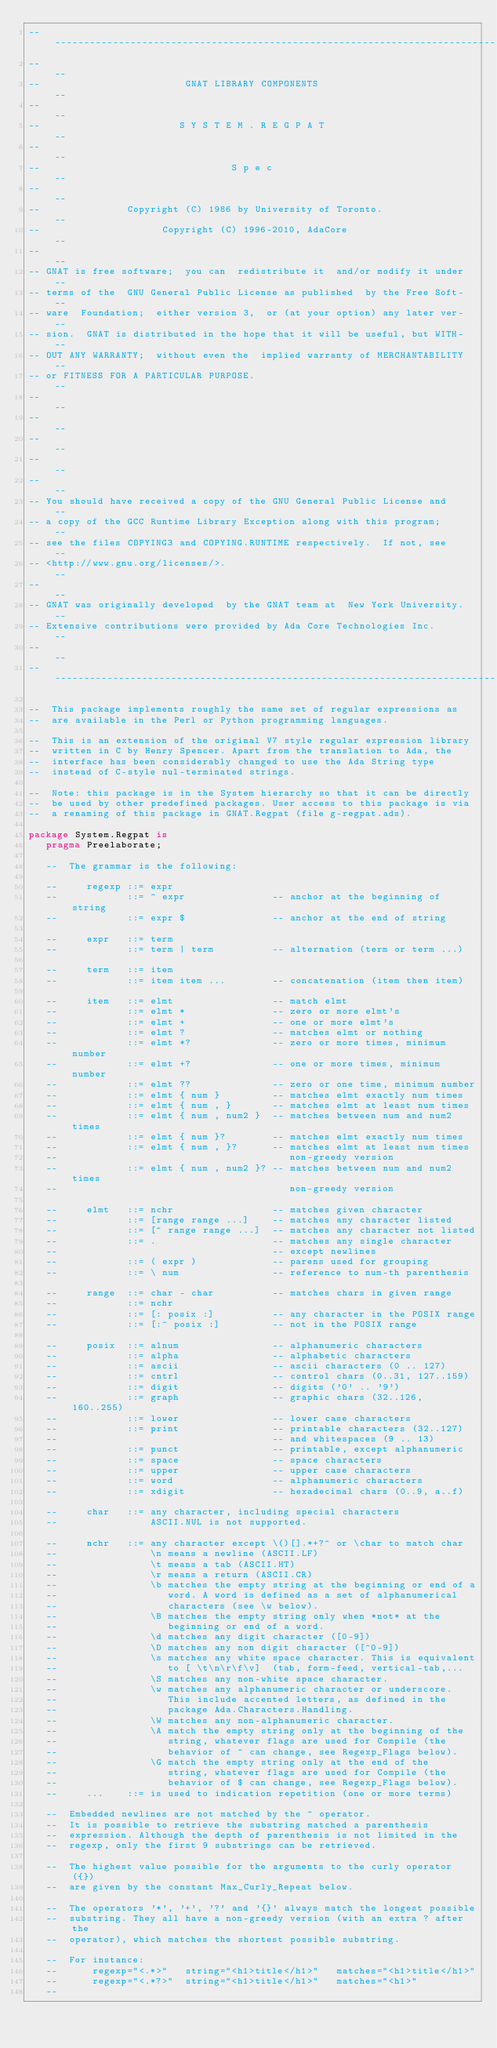Convert code to text. <code><loc_0><loc_0><loc_500><loc_500><_Ada_>------------------------------------------------------------------------------
--                                                                          --
--                         GNAT LIBRARY COMPONENTS                          --
--                                                                          --
--                        S Y S T E M . R E G P A T                         --
--                                                                          --
--                                 S p e c                                  --
--                                                                          --
--               Copyright (C) 1986 by University of Toronto.               --
--                     Copyright (C) 1996-2010, AdaCore                     --
--                                                                          --
-- GNAT is free software;  you can  redistribute it  and/or modify it under --
-- terms of the  GNU General Public License as published  by the Free Soft- --
-- ware  Foundation;  either version 3,  or (at your option) any later ver- --
-- sion.  GNAT is distributed in the hope that it will be useful, but WITH- --
-- OUT ANY WARRANTY;  without even the  implied warranty of MERCHANTABILITY --
-- or FITNESS FOR A PARTICULAR PURPOSE.                                     --
--                                                                          --
--                                                                          --
--                                                                          --
--                                                                          --
--                                                                          --
-- You should have received a copy of the GNU General Public License and    --
-- a copy of the GCC Runtime Library Exception along with this program;     --
-- see the files COPYING3 and COPYING.RUNTIME respectively.  If not, see    --
-- <http://www.gnu.org/licenses/>.                                          --
--                                                                          --
-- GNAT was originally developed  by the GNAT team at  New York University. --
-- Extensive contributions were provided by Ada Core Technologies Inc.      --
--                                                                          --
------------------------------------------------------------------------------

--  This package implements roughly the same set of regular expressions as
--  are available in the Perl or Python programming languages.

--  This is an extension of the original V7 style regular expression library
--  written in C by Henry Spencer. Apart from the translation to Ada, the
--  interface has been considerably changed to use the Ada String type
--  instead of C-style nul-terminated strings.

--  Note: this package is in the System hierarchy so that it can be directly
--  be used by other predefined packages. User access to this package is via
--  a renaming of this package in GNAT.Regpat (file g-regpat.ads).

package System.Regpat is
   pragma Preelaborate;

   --  The grammar is the following:

   --     regexp ::= expr
   --            ::= ^ expr               -- anchor at the beginning of string
   --            ::= expr $               -- anchor at the end of string

   --     expr   ::= term
   --            ::= term | term          -- alternation (term or term ...)

   --     term   ::= item
   --            ::= item item ...        -- concatenation (item then item)

   --     item   ::= elmt                 -- match elmt
   --            ::= elmt *               -- zero or more elmt's
   --            ::= elmt +               -- one or more elmt's
   --            ::= elmt ?               -- matches elmt or nothing
   --            ::= elmt *?              -- zero or more times, minimum number
   --            ::= elmt +?              -- one or more times, minimum number
   --            ::= elmt ??              -- zero or one time, minimum number
   --            ::= elmt { num }         -- matches elmt exactly num times
   --            ::= elmt { num , }       -- matches elmt at least num times
   --            ::= elmt { num , num2 }  -- matches between num and num2 times
   --            ::= elmt { num }?        -- matches elmt exactly num times
   --            ::= elmt { num , }?      -- matches elmt at least num times
   --                                        non-greedy version
   --            ::= elmt { num , num2 }? -- matches between num and num2 times
   --                                        non-greedy version

   --     elmt   ::= nchr                 -- matches given character
   --            ::= [range range ...]    -- matches any character listed
   --            ::= [^ range range ...]  -- matches any character not listed
   --            ::= .                    -- matches any single character
   --                                     -- except newlines
   --            ::= ( expr )             -- parens used for grouping
   --            ::= \ num                -- reference to num-th parenthesis

   --     range  ::= char - char          -- matches chars in given range
   --            ::= nchr
   --            ::= [: posix :]          -- any character in the POSIX range
   --            ::= [:^ posix :]         -- not in the POSIX range

   --     posix  ::= alnum                -- alphanumeric characters
   --            ::= alpha                -- alphabetic characters
   --            ::= ascii                -- ascii characters (0 .. 127)
   --            ::= cntrl                -- control chars (0..31, 127..159)
   --            ::= digit                -- digits ('0' .. '9')
   --            ::= graph                -- graphic chars (32..126, 160..255)
   --            ::= lower                -- lower case characters
   --            ::= print                -- printable characters (32..127)
   --                                     -- and whitespaces (9 .. 13)
   --            ::= punct                -- printable, except alphanumeric
   --            ::= space                -- space characters
   --            ::= upper                -- upper case characters
   --            ::= word                 -- alphanumeric characters
   --            ::= xdigit               -- hexadecimal chars (0..9, a..f)

   --     char   ::= any character, including special characters
   --                ASCII.NUL is not supported.

   --     nchr   ::= any character except \()[].*+?^ or \char to match char
   --                \n means a newline (ASCII.LF)
   --                \t means a tab (ASCII.HT)
   --                \r means a return (ASCII.CR)
   --                \b matches the empty string at the beginning or end of a
   --                   word. A word is defined as a set of alphanumerical
   --                   characters (see \w below).
   --                \B matches the empty string only when *not* at the
   --                   beginning or end of a word.
   --                \d matches any digit character ([0-9])
   --                \D matches any non digit character ([^0-9])
   --                \s matches any white space character. This is equivalent
   --                   to [ \t\n\r\f\v]  (tab, form-feed, vertical-tab,...
   --                \S matches any non-white space character.
   --                \w matches any alphanumeric character or underscore.
   --                   This include accented letters, as defined in the
   --                   package Ada.Characters.Handling.
   --                \W matches any non-alphanumeric character.
   --                \A match the empty string only at the beginning of the
   --                   string, whatever flags are used for Compile (the
   --                   behavior of ^ can change, see Regexp_Flags below).
   --                \G match the empty string only at the end of the
   --                   string, whatever flags are used for Compile (the
   --                   behavior of $ can change, see Regexp_Flags below).
   --     ...    ::= is used to indication repetition (one or more terms)

   --  Embedded newlines are not matched by the ^ operator.
   --  It is possible to retrieve the substring matched a parenthesis
   --  expression. Although the depth of parenthesis is not limited in the
   --  regexp, only the first 9 substrings can be retrieved.

   --  The highest value possible for the arguments to the curly operator ({})
   --  are given by the constant Max_Curly_Repeat below.

   --  The operators '*', '+', '?' and '{}' always match the longest possible
   --  substring. They all have a non-greedy version (with an extra ? after the
   --  operator), which matches the shortest possible substring.

   --  For instance:
   --      regexp="<.*>"   string="<h1>title</h1>"   matches="<h1>title</h1>"
   --      regexp="<.*?>"  string="<h1>title</h1>"   matches="<h1>"
   --</code> 